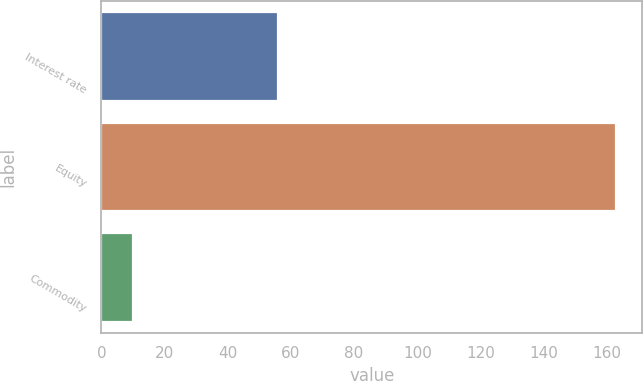<chart> <loc_0><loc_0><loc_500><loc_500><bar_chart><fcel>Interest rate<fcel>Equity<fcel>Commodity<nl><fcel>56<fcel>163<fcel>10<nl></chart> 